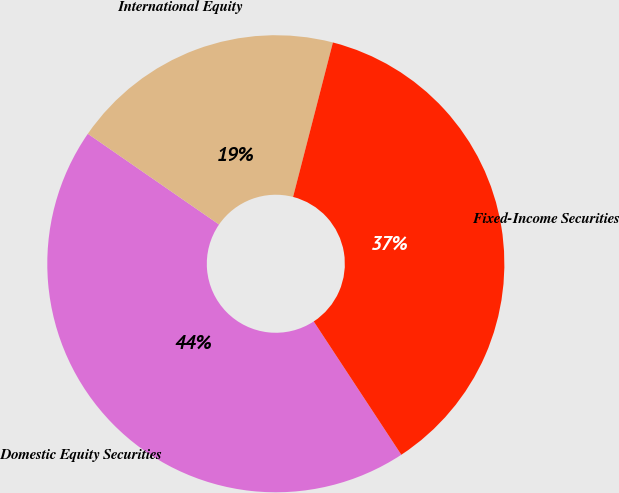Convert chart. <chart><loc_0><loc_0><loc_500><loc_500><pie_chart><fcel>Domestic Equity Securities<fcel>International Equity<fcel>Fixed-Income Securities<nl><fcel>43.88%<fcel>19.39%<fcel>36.73%<nl></chart> 